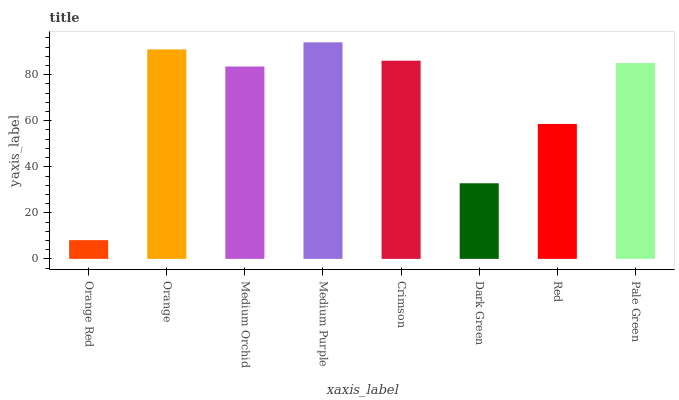Is Orange Red the minimum?
Answer yes or no. Yes. Is Medium Purple the maximum?
Answer yes or no. Yes. Is Orange the minimum?
Answer yes or no. No. Is Orange the maximum?
Answer yes or no. No. Is Orange greater than Orange Red?
Answer yes or no. Yes. Is Orange Red less than Orange?
Answer yes or no. Yes. Is Orange Red greater than Orange?
Answer yes or no. No. Is Orange less than Orange Red?
Answer yes or no. No. Is Pale Green the high median?
Answer yes or no. Yes. Is Medium Orchid the low median?
Answer yes or no. Yes. Is Red the high median?
Answer yes or no. No. Is Crimson the low median?
Answer yes or no. No. 